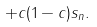<formula> <loc_0><loc_0><loc_500><loc_500>+ c ( 1 - c ) s _ { n } .</formula> 